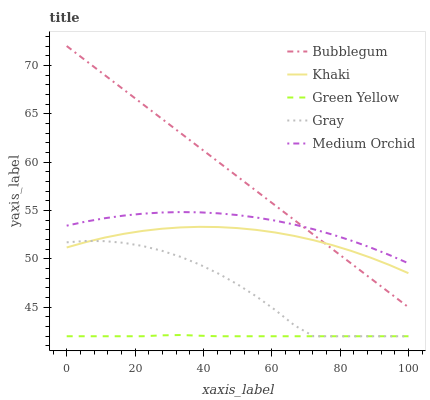Does Khaki have the minimum area under the curve?
Answer yes or no. No. Does Khaki have the maximum area under the curve?
Answer yes or no. No. Is Green Yellow the smoothest?
Answer yes or no. No. Is Green Yellow the roughest?
Answer yes or no. No. Does Khaki have the lowest value?
Answer yes or no. No. Does Khaki have the highest value?
Answer yes or no. No. Is Khaki less than Medium Orchid?
Answer yes or no. Yes. Is Medium Orchid greater than Khaki?
Answer yes or no. Yes. Does Khaki intersect Medium Orchid?
Answer yes or no. No. 